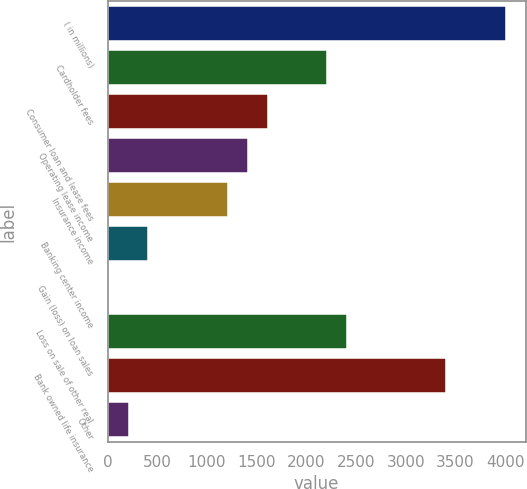Convert chart to OTSL. <chart><loc_0><loc_0><loc_500><loc_500><bar_chart><fcel>( in millions)<fcel>Cardholder fees<fcel>Consumer loan and lease fees<fcel>Operating lease income<fcel>Insurance income<fcel>Banking center income<fcel>Gain (loss) on loan sales<fcel>Loss on sale of other real<fcel>Bank owned life insurance<fcel>Other<nl><fcel>4005<fcel>2207.7<fcel>1608.6<fcel>1408.9<fcel>1209.2<fcel>410.4<fcel>11<fcel>2407.4<fcel>3405.9<fcel>210.7<nl></chart> 